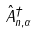Convert formula to latex. <formula><loc_0><loc_0><loc_500><loc_500>\hat { A } _ { n , \alpha } ^ { \dagger }</formula> 